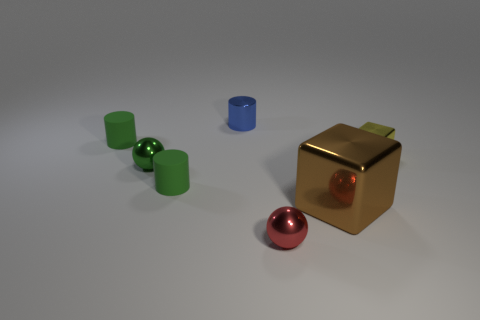What is the material of the tiny green cylinder on the right side of the tiny green matte thing to the left of the sphere that is on the left side of the tiny red sphere? Based on the image, the material of the tiny green cylinder cannot be determined with absolute certainty without physical inspection, but given its appearance and common manufacturing practices, it is likely to be made of plastic or metal with a painted or anodized finish to achieve the matte green appearance. 